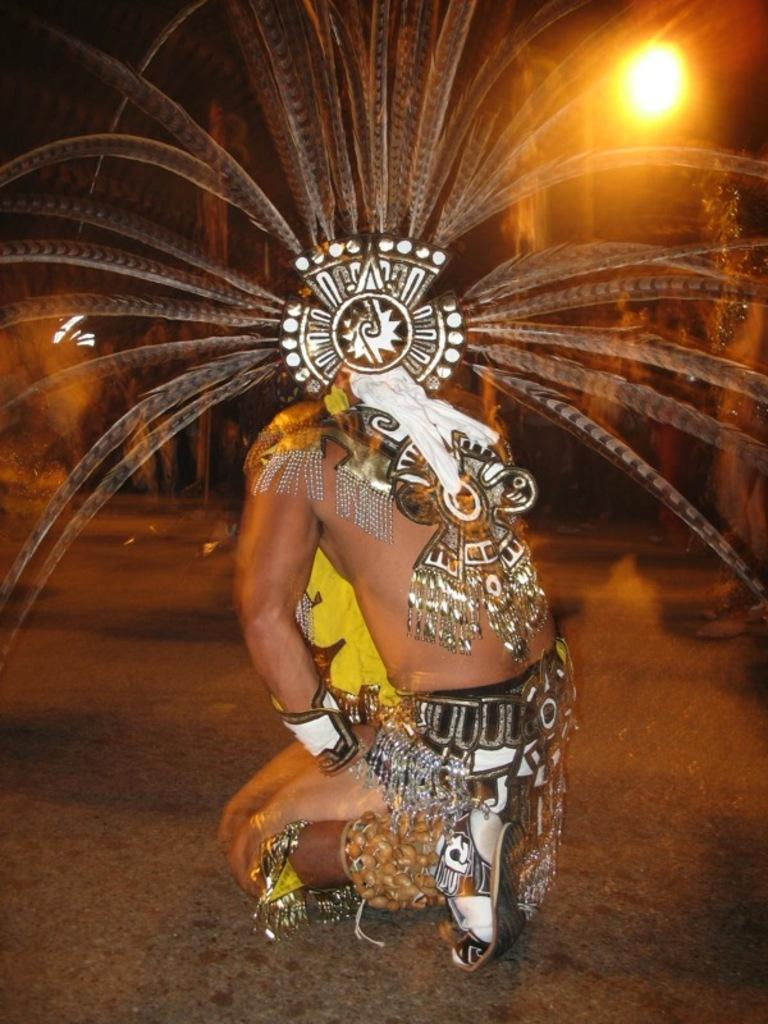What is the main subject of the image? There is a person in the image. What is the person doing in the image? The person is sitting on the ground. What is the person wearing in the image? The person is wearing a costume. What type of police coat can be seen in the image? There is no police coat present in the image. What type of street is visible in the image? There is no street visible in the image. 